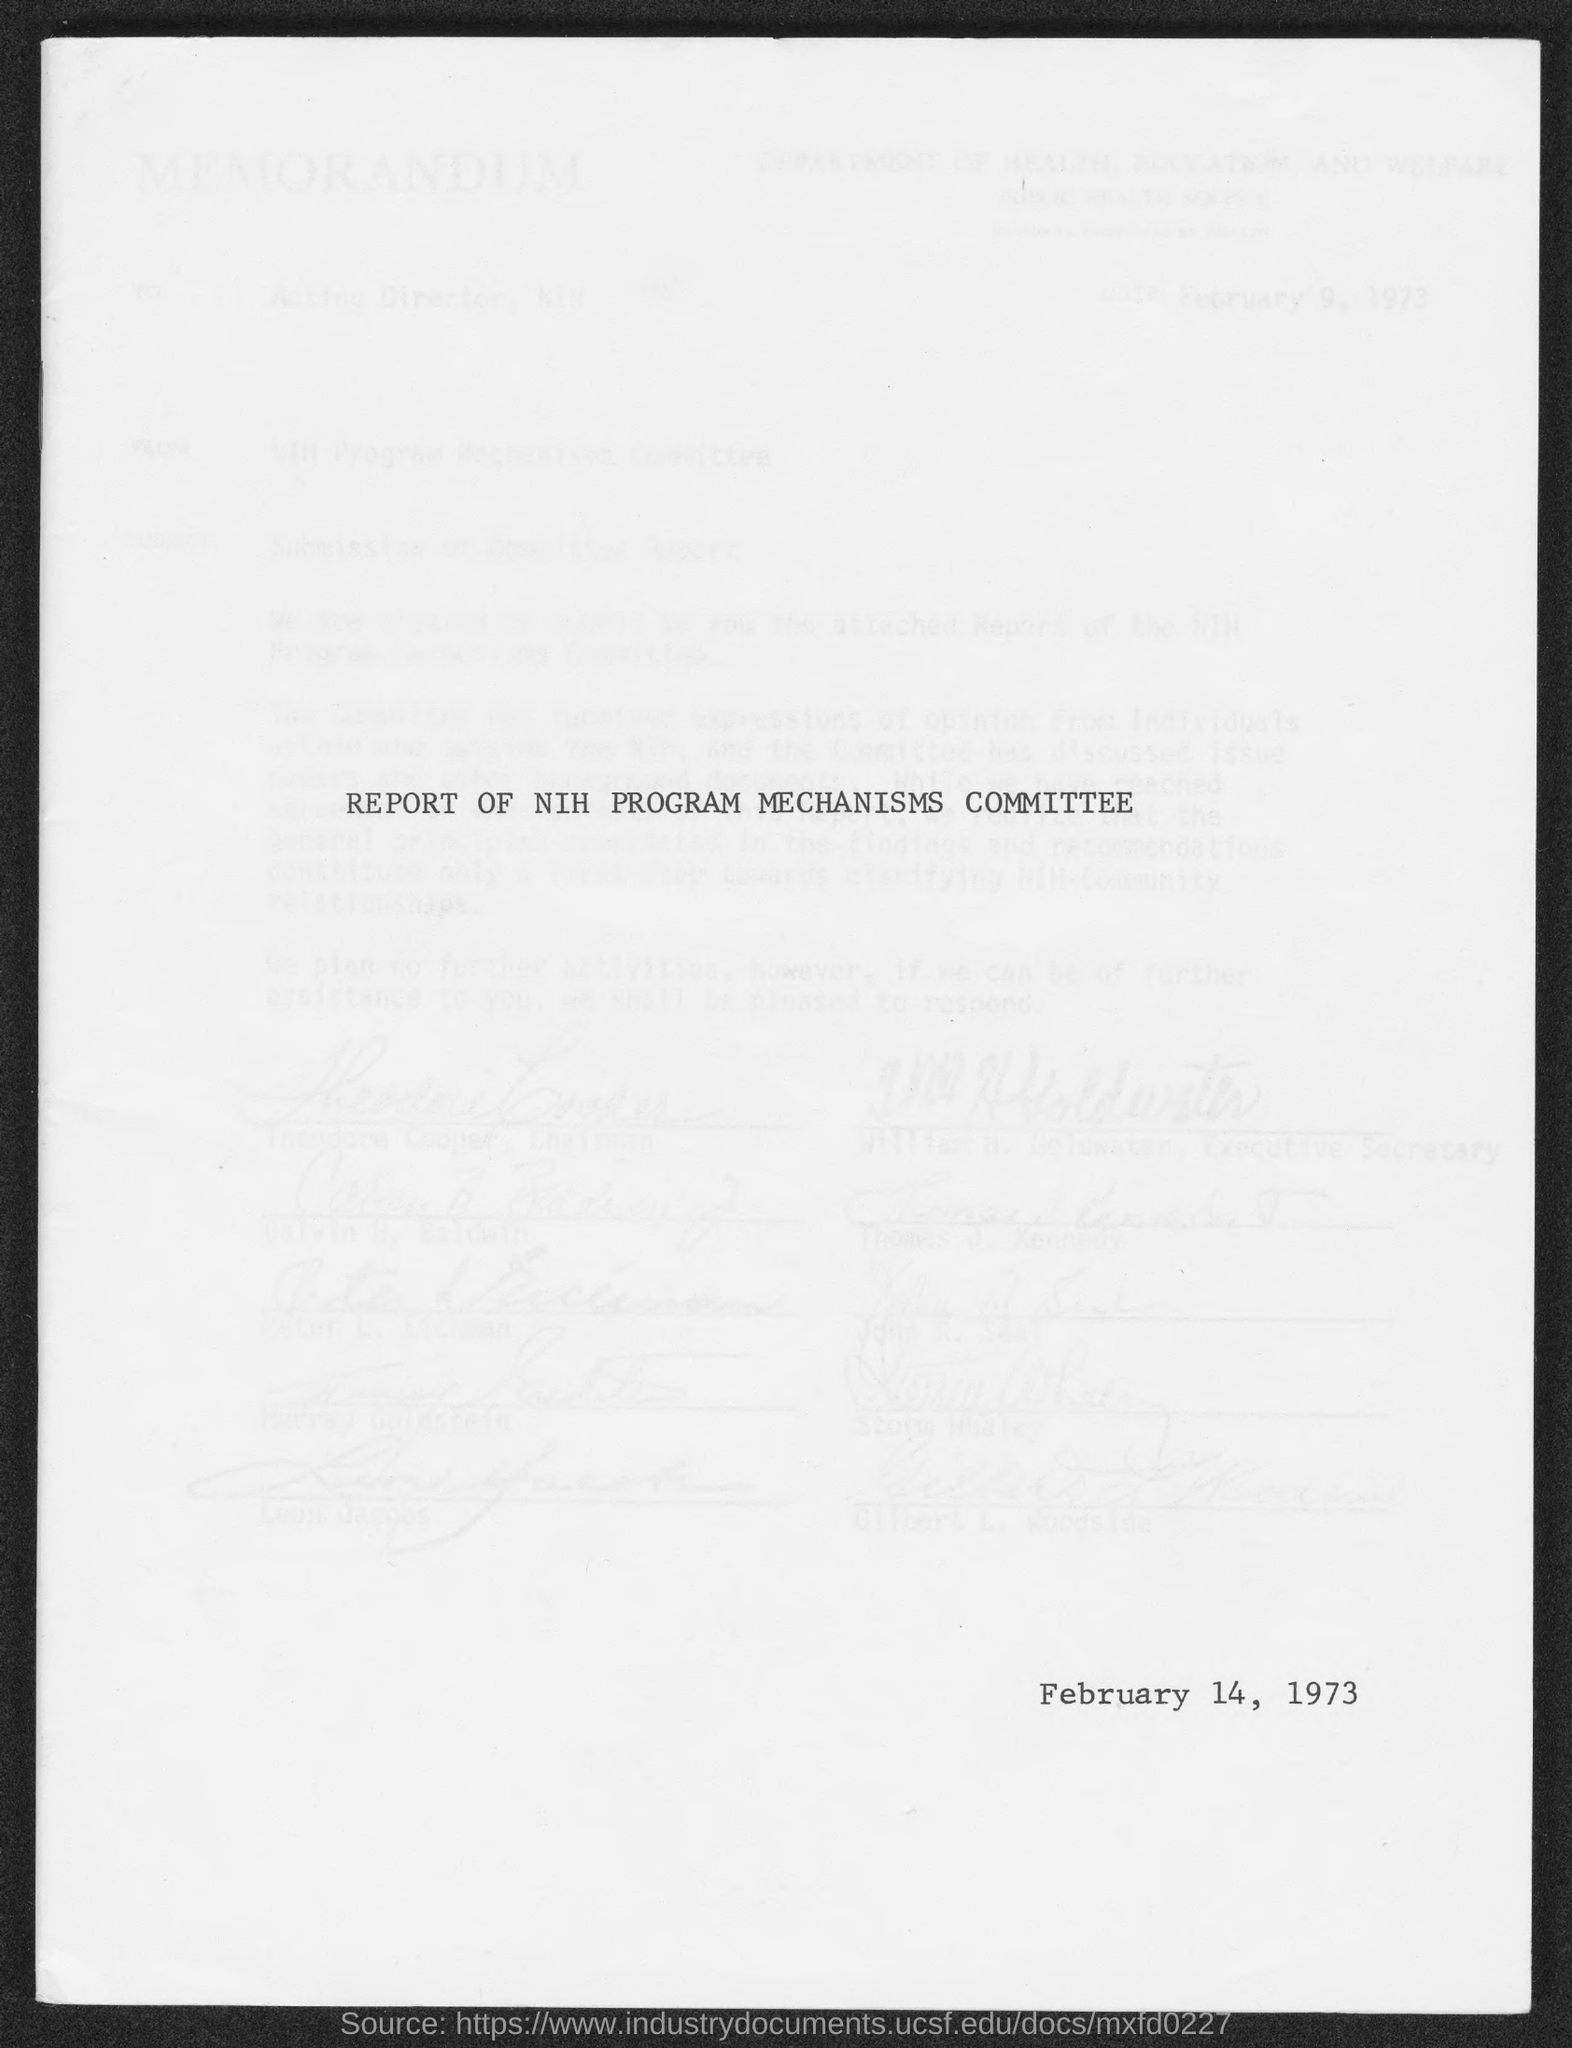What is the date mentioned in this document?
Offer a terse response. February 14, 1973. 